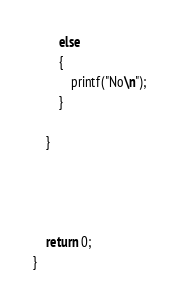Convert code to text. <code><loc_0><loc_0><loc_500><loc_500><_C_>		else 
		{
			printf("No\n");
		}

	}




	return 0;
}
</code> 